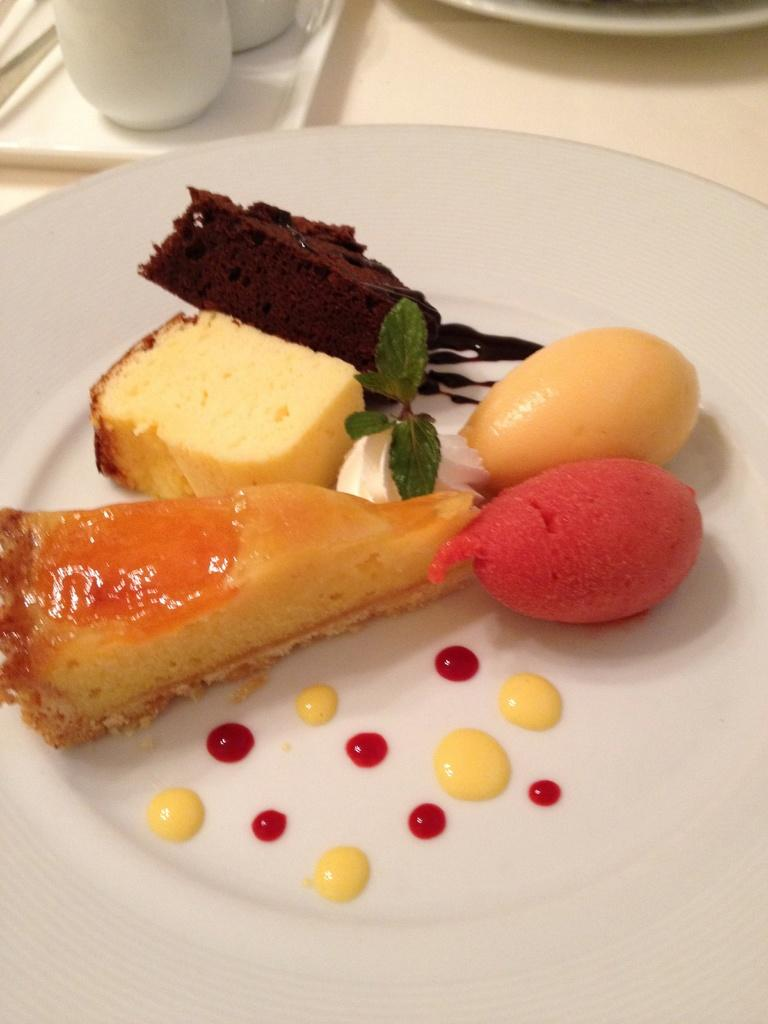What is the main object in the center of the image? There is a table in the center of the image. What can be found on the table? There are plates and cups on the table. What is on the plates? The plates contain different flavors of cake pieces, mint leaves, cream, and other food items. How many girls are sitting at the table in the image? There is no mention of girls in the image, so we cannot determine the number of girls present. What type of berry can be seen on the plates in the image? There is no mention of berries in the image, so we cannot determine if any berries are present. 